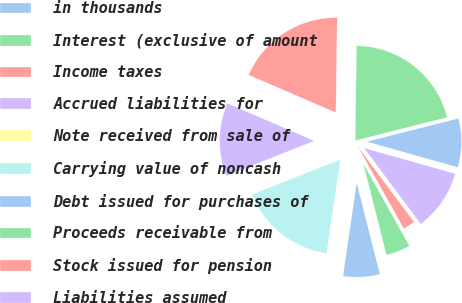Convert chart. <chart><loc_0><loc_0><loc_500><loc_500><pie_chart><fcel>in thousands<fcel>Interest (exclusive of amount<fcel>Income taxes<fcel>Accrued liabilities for<fcel>Note received from sale of<fcel>Carrying value of noncash<fcel>Debt issued for purchases of<fcel>Proceeds receivable from<fcel>Stock issued for pension<fcel>Liabilities assumed<nl><fcel>8.33%<fcel>20.83%<fcel>18.75%<fcel>12.5%<fcel>0.0%<fcel>16.67%<fcel>6.25%<fcel>4.17%<fcel>2.08%<fcel>10.42%<nl></chart> 